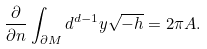<formula> <loc_0><loc_0><loc_500><loc_500>\frac { \partial } { \partial n } \int _ { \partial M } d ^ { d - 1 } y \sqrt { - h } = 2 \pi A .</formula> 